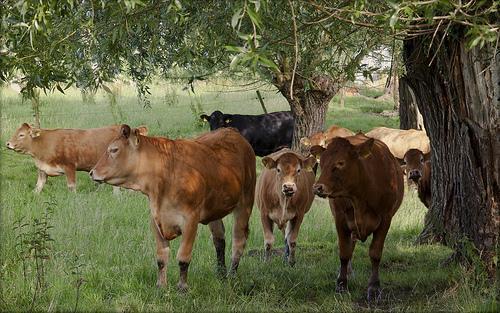How many black cows are there?
Give a very brief answer. 1. How many cows are visible?
Give a very brief answer. 8. How many cows are looking directly at the camera?
Give a very brief answer. 2. 